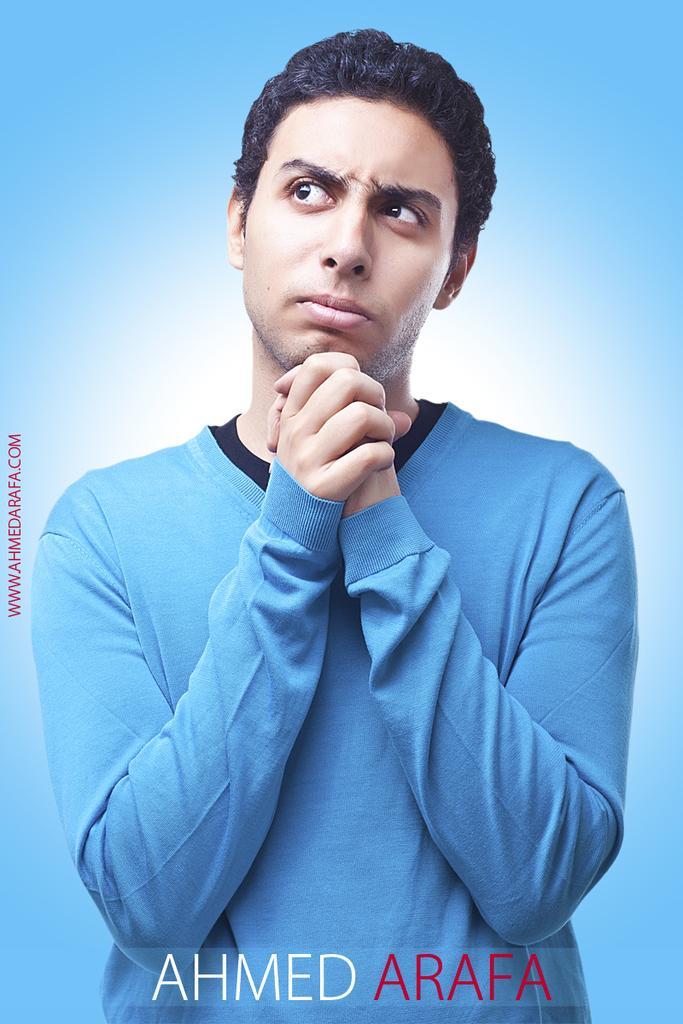Describe this image in one or two sentences. In this image we can see a person wearing a t-shirt. There is a text at the bottom of the image. The background of the image is blue in color. 